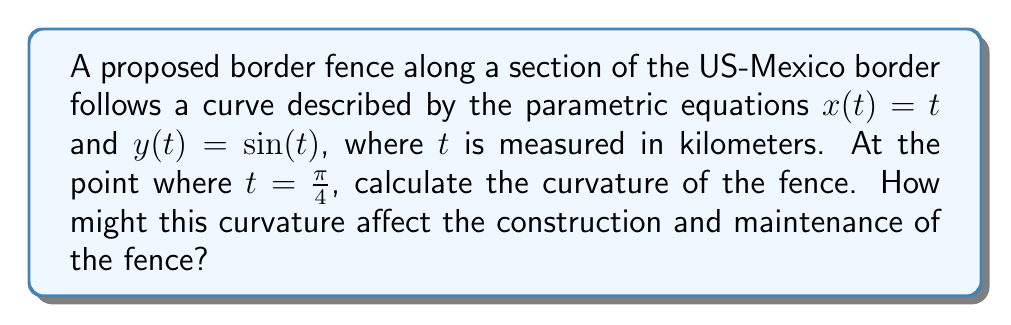Can you solve this math problem? To calculate the curvature of the border fence, we'll use the formula for curvature in parametric form:

$$\kappa = \frac{|x'y'' - y'x''|}{(x'^2 + y'^2)^{3/2}}$$

Step 1: Calculate the first and second derivatives of $x(t)$ and $y(t)$.
$x'(t) = 1$
$x''(t) = 0$
$y'(t) = \cos(t)$
$y''(t) = -\sin(t)$

Step 2: Substitute these values into the curvature formula at $t = \frac{\pi}{4}$.
$$\kappa = \frac{|1 \cdot (-\sin(\frac{\pi}{4})) - \cos(\frac{\pi}{4}) \cdot 0|}{(1^2 + \cos^2(\frac{\pi}{4}))^{3/2}}$$

Step 3: Simplify using known values of sine and cosine at $\frac{\pi}{4}$.
$\sin(\frac{\pi}{4}) = \cos(\frac{\pi}{4}) = \frac{\sqrt{2}}{2}$

$$\kappa = \frac{|-\frac{\sqrt{2}}{2}|}{(1 + (\frac{\sqrt{2}}{2})^2)^{3/2}} = \frac{\frac{\sqrt{2}}{2}}{(\frac{3}{2})^{3/2}}$$

Step 4: Simplify the final expression.
$$\kappa = \frac{\sqrt{2}}{2} \cdot \frac{2\sqrt{2}}{3\sqrt{3}} = \frac{2}{3\sqrt{3}}$$

The curvature at this point affects the construction and maintenance of the fence by requiring additional structural support to maintain its shape and integrity. A higher curvature means a sharper bend, which could increase material stress and potentially require more frequent inspections and repairs.
Answer: $\frac{2}{3\sqrt{3}}$ km$^{-1}$ 